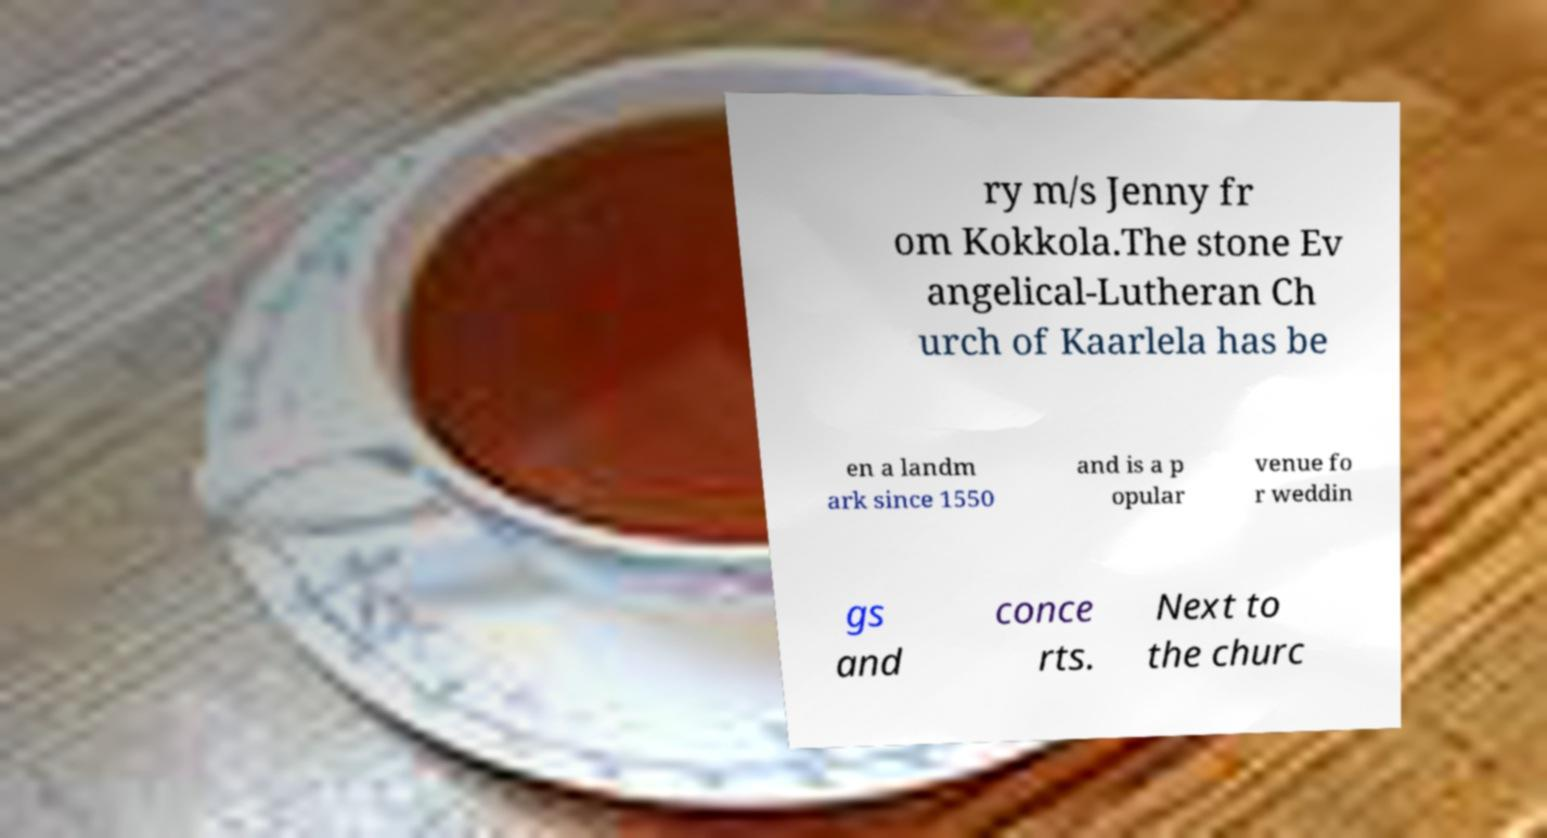Can you accurately transcribe the text from the provided image for me? ry m/s Jenny fr om Kokkola.The stone Ev angelical-Lutheran Ch urch of Kaarlela has be en a landm ark since 1550 and is a p opular venue fo r weddin gs and conce rts. Next to the churc 